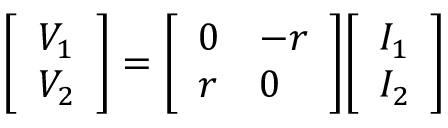<formula> <loc_0><loc_0><loc_500><loc_500>{ \left [ \begin{array} { l } { V _ { 1 } } \\ { V _ { 2 } } \end{array} \right ] } = { \left [ \begin{array} { l l } { 0 } & { - r } \\ { r } & { 0 } \end{array} \right ] } { \left [ \begin{array} { l } { I _ { 1 } } \\ { I _ { 2 } } \end{array} \right ] }</formula> 